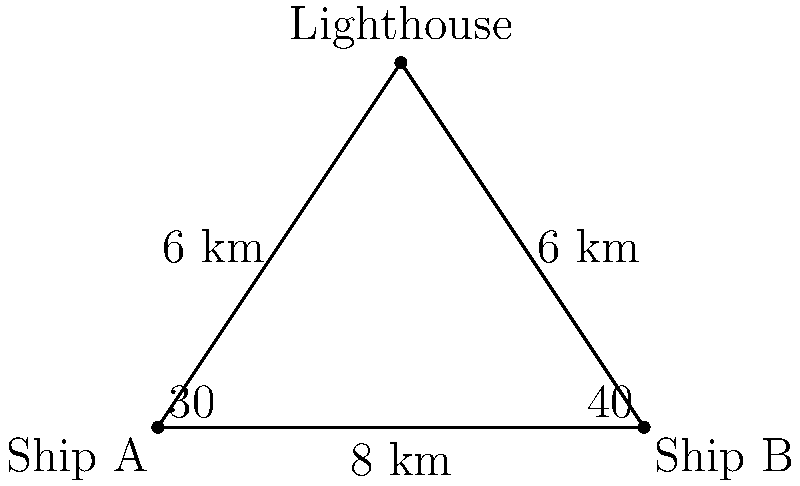In a nautical scenario reminiscent of a passage from Joseph Conrad's "The Mirror of the Sea," two ships, A and B, are observed from a coastal lighthouse. The lighthouse is 6 km away from each ship, and the angle between the lines of sight to the ships is $70°$. What is the distance between the two ships? Round your answer to the nearest tenth of a kilometer. Let's approach this problem step-by-step using the law of cosines:

1) We have a triangle with three known elements:
   - Two sides (CA and CB) are both 6 km
   - The angle between these sides is $70°$

2) We need to find the third side (AB), which represents the distance between the ships.

3) The law of cosines states:
   $c^2 = a^2 + b^2 - 2ab \cos(C)$
   
   Where:
   $c$ is the side we're looking for (AB)
   $a$ and $b$ are the known sides (both 6 km)
   $C$ is the known angle ($70°$)

4) Let's substitute these values:
   $AB^2 = 6^2 + 6^2 - 2(6)(6) \cos(70°)$

5) Simplify:
   $AB^2 = 36 + 36 - 72 \cos(70°)$
   $AB^2 = 72 - 72 \cos(70°)$

6) Calculate:
   $\cos(70°) \approx 0.3420$
   $AB^2 = 72 - 72(0.3420) = 72 - 24.624 = 47.376$

7) Take the square root:
   $AB = \sqrt{47.376} \approx 6.8830$

8) Rounding to the nearest tenth:
   $AB \approx 6.9$ km

Thus, the distance between the two ships is approximately 6.9 km.
Answer: 6.9 km 